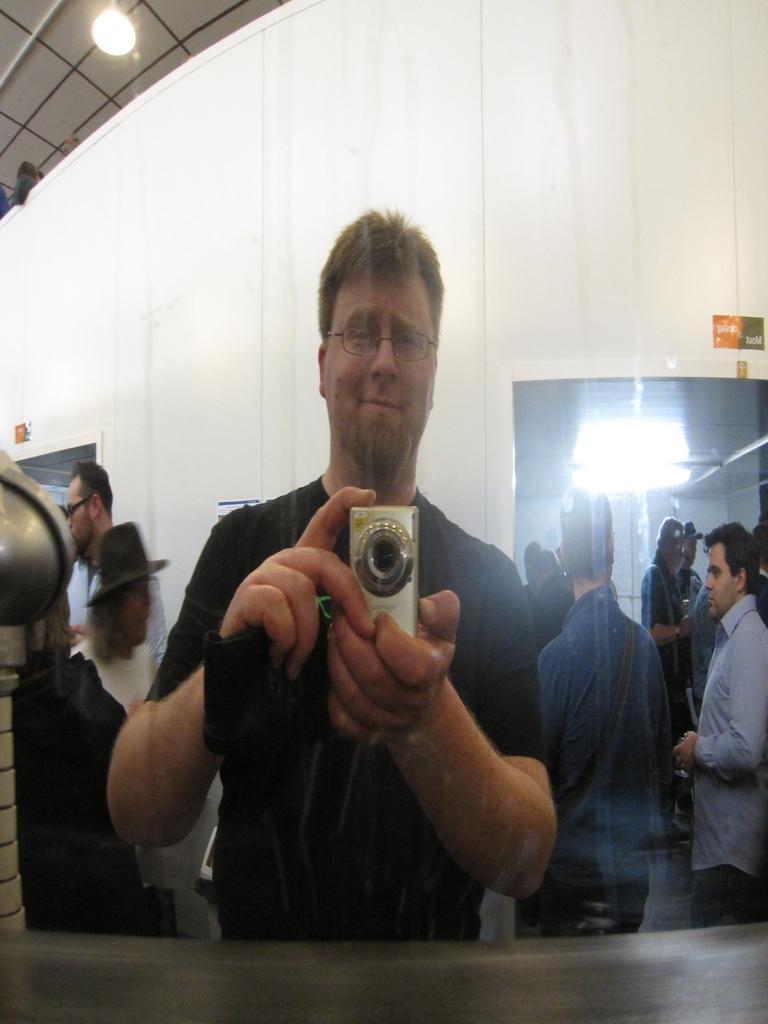Can you describe this image briefly? This image consists of a man holding a camera. It looks like he is standing in front of the camera. In the background, there are many people and a wall in white color. At the top, we can see a roof along with a lamp. 